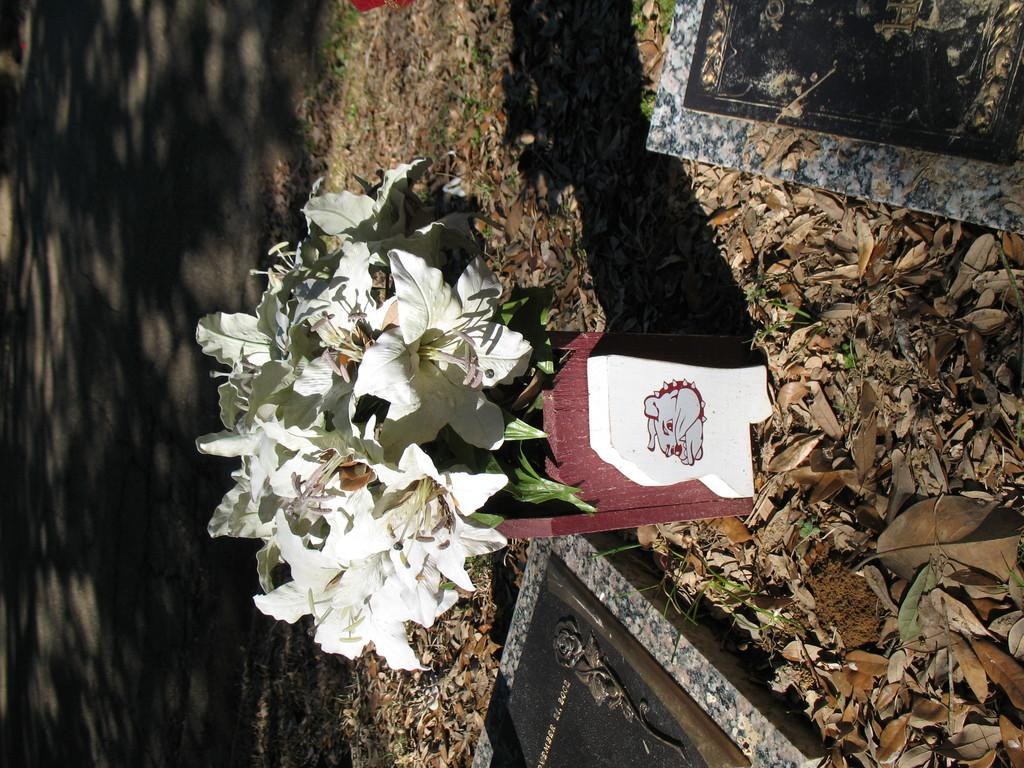What type of plant is in the potted plant in the image? The provided facts do not specify the type of plant in the potted plant. What can be observed around the potted plant? There are many dry leaves around the potted plant. What other objects are present in the image? There are two marble stones in the image. What can be seen in the background of the image? There is a road visible in the background of the image. What color is the stocking on the father's leg in the image? There is no father or stocking present in the image; it only features a potted plant, dry leaves, marble stones, and a road in the background. 